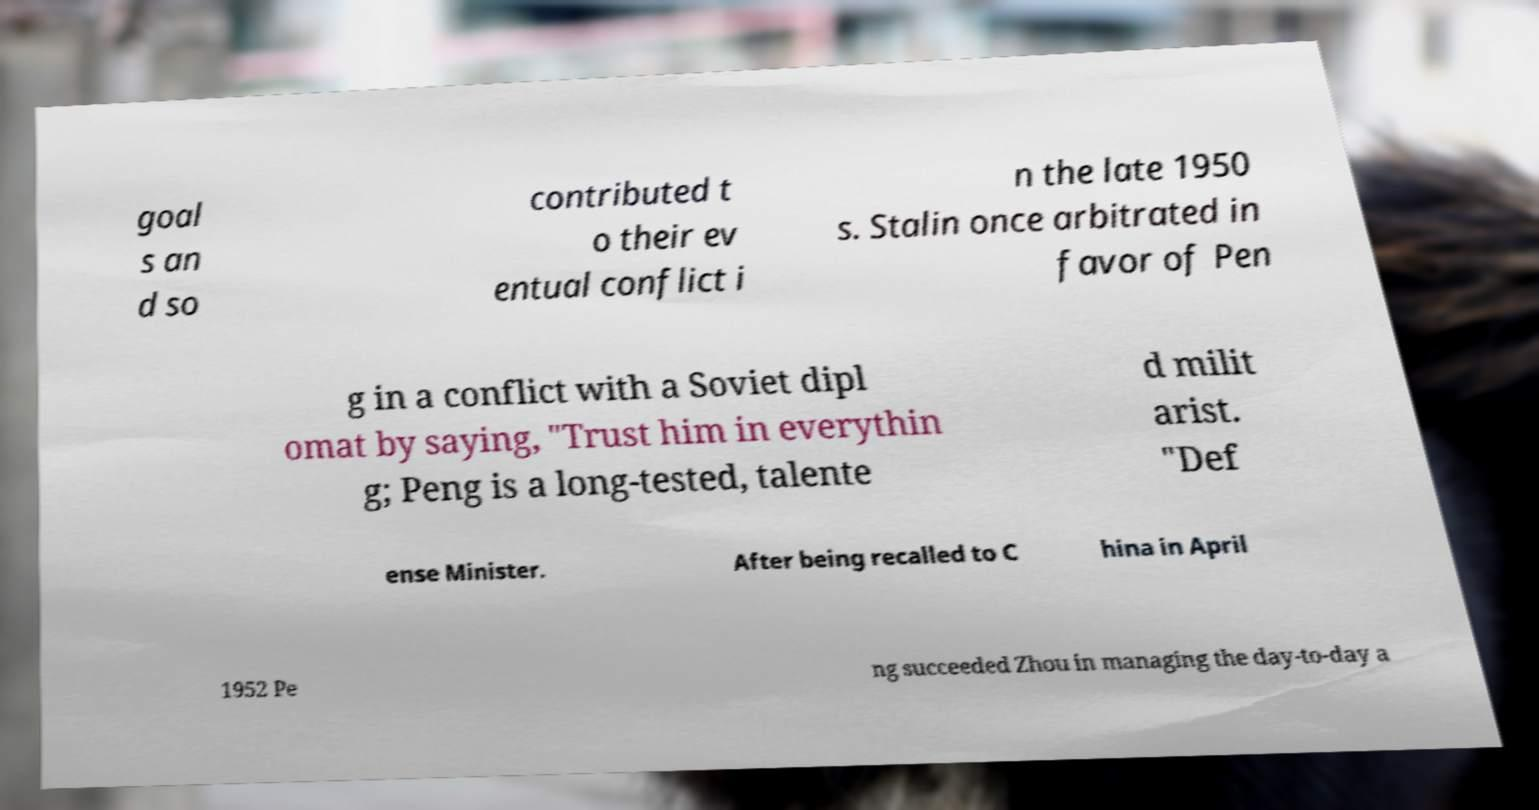Can you read and provide the text displayed in the image?This photo seems to have some interesting text. Can you extract and type it out for me? goal s an d so contributed t o their ev entual conflict i n the late 1950 s. Stalin once arbitrated in favor of Pen g in a conflict with a Soviet dipl omat by saying, "Trust him in everythin g; Peng is a long-tested, talente d milit arist. "Def ense Minister. After being recalled to C hina in April 1952 Pe ng succeeded Zhou in managing the day-to-day a 